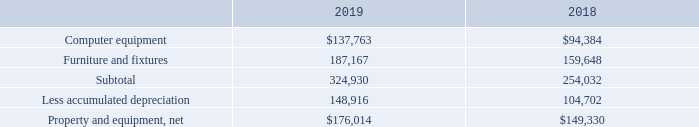NOTE 5 – PROPERTY AND EQUIPMENT
The Company owned equipment recorded at cost, which consisted of the following as of December 31, 2019 and 2018:
Depreciation expense was $80,206 and $58,423 for the years ended December 31, 2019 and 2018, respectively
What was the depreciation expense in 2018? $58,423. What were the net costs of property and equipment that the Company owned in 2018 and 2019, respectively? $149,330, $176,014. What was the cost of computer equipment in 2018? $94,384. What is the average subtotal cost of property and equipment that the Company owned from 2018 to 2019? (324,930+254,032)/2 
Answer: 289481. What is the percentage change in the net cost of property and equipment from 2018 to 2019?
Answer scale should be: percent. (176,014-149,330)/149,330 
Answer: 17.87. What is the ratio of depreciation expense to accumulated depreciation of property and equipment in 2019? 80,206/148,916 
Answer: 0.54. 